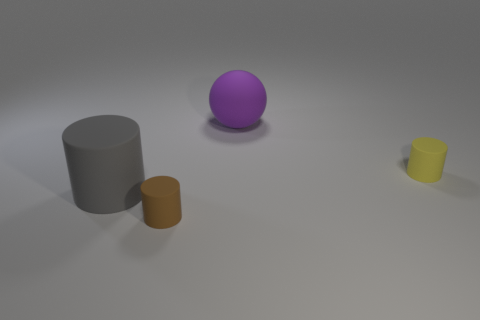There is a purple object that is made of the same material as the gray cylinder; what is its size?
Give a very brief answer. Large. There is a cylinder that is on the right side of the brown rubber cylinder; what material is it?
Your response must be concise. Rubber. What number of large objects are either gray objects or purple things?
Give a very brief answer. 2. Is there a large purple ball made of the same material as the gray cylinder?
Provide a short and direct response. Yes. Does the cylinder on the right side of the brown matte cylinder have the same size as the purple matte object?
Offer a terse response. No. Are there any tiny matte cylinders to the right of the small cylinder that is behind the big object that is to the left of the big matte sphere?
Give a very brief answer. No. What number of shiny things are yellow objects or large gray cylinders?
Your answer should be very brief. 0. How many other objects are the same shape as the tiny yellow thing?
Your answer should be very brief. 2. Are there more large purple balls than cylinders?
Keep it short and to the point. No. What size is the cylinder on the left side of the small rubber cylinder that is left of the cylinder that is right of the brown cylinder?
Give a very brief answer. Large. 